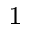Convert formula to latex. <formula><loc_0><loc_0><loc_500><loc_500>^ { 1 }</formula> 